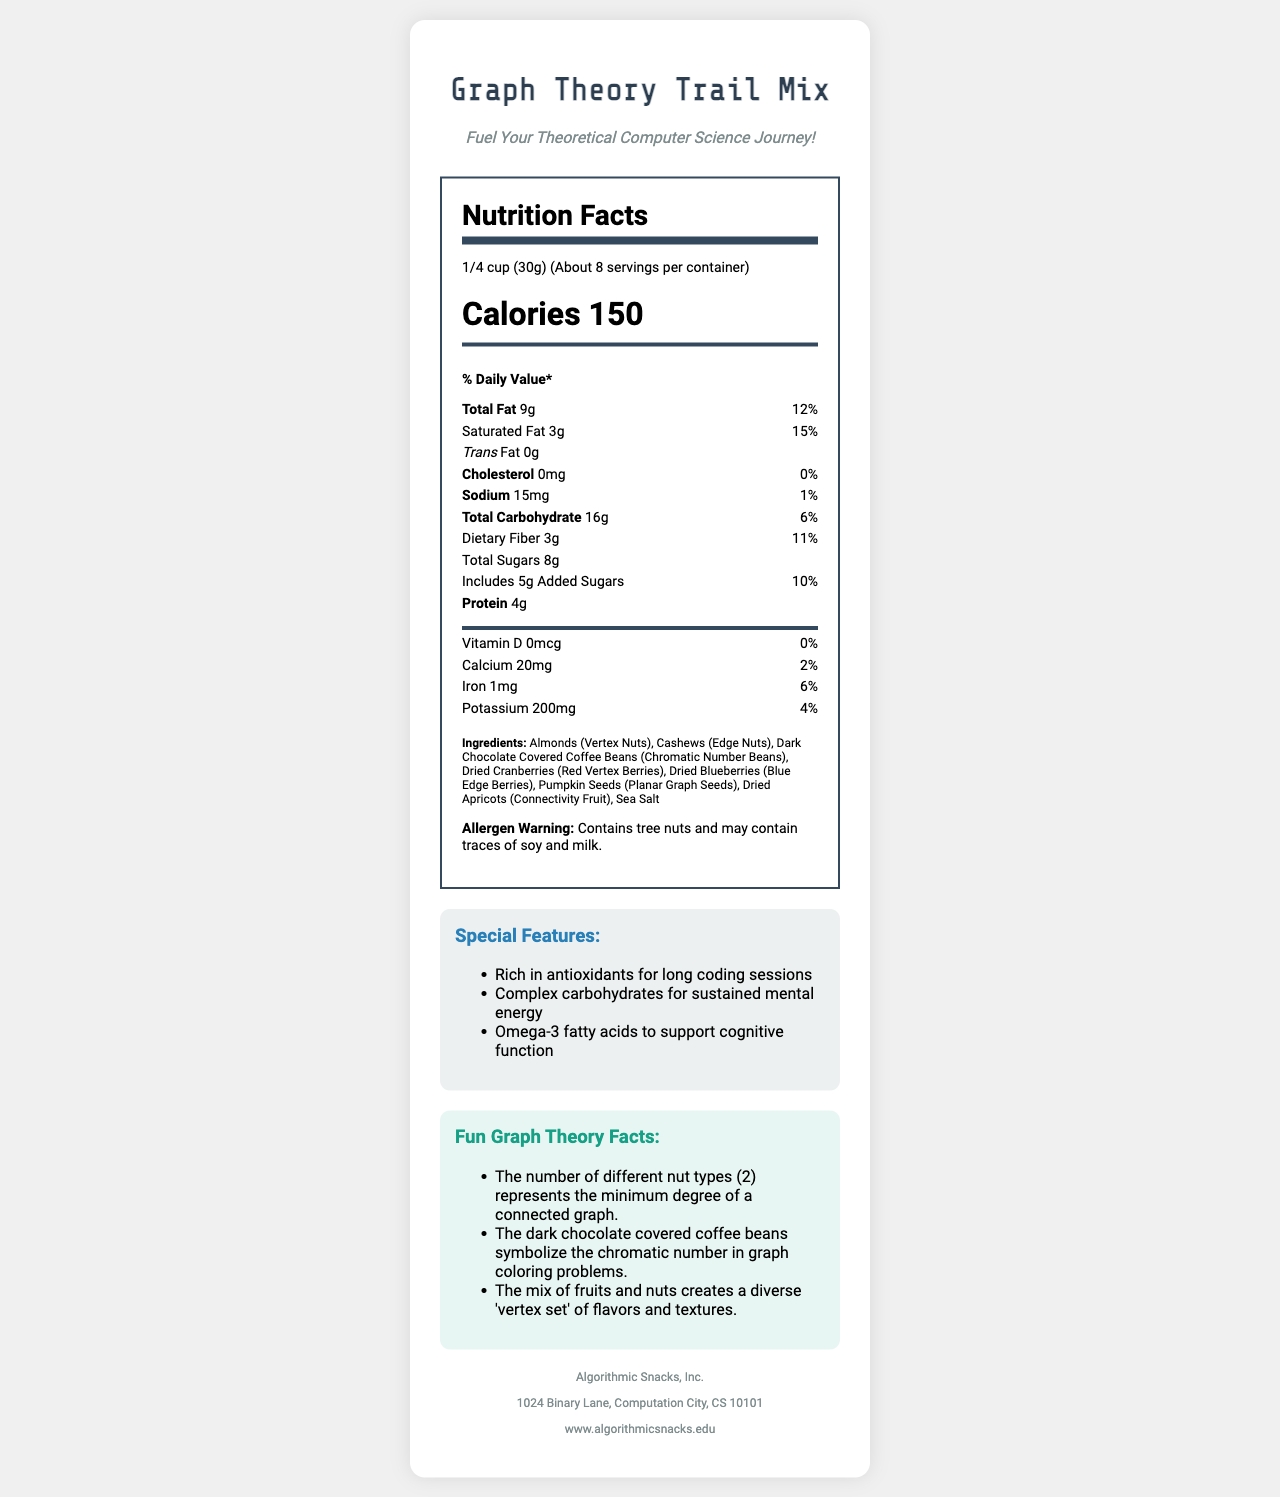what is the serving size? The serving size is given at the top of the Nutrition Facts label.
Answer: 1/4 cup (30g) how many calories are in one serving? The calories per serving are prominently displayed under the serving size information.
Answer: 150 which ingredient is labeled as "Chromatic Number Beans"? The ingredients list includes "Dark Chocolate Covered Coffee Beans" with the description "Chromatic Number Beans" in parentheses.
Answer: Dark Chocolate Covered Coffee Beans what is the daily value percentage of total fat per serving? The daily value percentage of total fat is 12%, as stated next to the total fat amount.
Answer: 12% true or false: this product contains no trans fat. The document explicitly states that the trans fat amount is "0g".
Answer: True how many servings are in one container? The number of servings per container is listed as "About 8" under the serving size.
Answer: About 8 which nutrient has the highest percent daily value? A. Saturated Fat B. Dietary Fiber C. Sodium Saturated Fat has the highest percent daily value at 15%, compared to Dietary Fiber (11%) and Sodium (1%).
Answer: A which company manufactures the Graph Theory Trail Mix? The manufacturer information at the bottom provides the name "Algorithmic Snacks, Inc.".
Answer: Algorithmic Snacks, Inc. how much protein does one serving contain? The protein content per serving is listed as 4g on the Nutrition Facts label.
Answer: 4g what are the special features of this trail mix? The special features section lists "Rich in antioxidants for long coding sessions," "Complex carbohydrates for sustained mental energy," and "Omega-3 fatty acids to support cognitive function."
Answer: Rich in antioxidants, Complex carbohydrates, Omega-3 fatty acids which two ingredients represent nuts in this trail mix? A. Almonds and Cashews B. Cashews and Pumpkin Seeds C. Almonds and Dried Apricots The ingredients list specifies Almonds as "Vertex Nuts" and Cashews as "Edge Nuts," thus, Almonds and Cashews are the nuts.
Answer: A what is the address of the manufacturer? The manufacturer information at the bottom includes the address "1024 Binary Lane, Computation City, CS 10101."
Answer: 1024 Binary Lane, Computation City, CS 10101 does the product contain any added sugars? The document indicates that there are 5g of added sugars per serving, with a 10% daily value.
Answer: Yes is vitamin D present in this trail mix? The amount of vitamin D is listed as "0mcg," and the percent daily value is also "0%."
Answer: No what is the main idea of this document? The document is a detailed description of the nutrition, ingredients, and other relevant information for the "Graph Theory Trail Mix".
Answer: It provides nutrition facts, ingredients, special features, fun facts, and manufacturer information about the "Graph Theory Trail Mix." how many fun facts are listed about the trail mix? The fun facts section contains three separate bullet points detailing different fun facts about the trail mix.
Answer: 3 what is the exact amount of dietary fiber in one serving? The nutrition facts list dietary fiber content as 3g per serving.
Answer: 3g which ingredient is not directly linked to graph theory terms? Most ingredients are linked to graph theory terms in parentheses, but Sea Salt does not have any such linkage.
Answer: Sea Salt who is mentioned as a theoretical computer science journey's fuel provider? The phrase "Fuel Your Theoretical Computer Science Journey!" is present but does not mention a specific provider.
Answer: Cannot be determined 